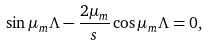Convert formula to latex. <formula><loc_0><loc_0><loc_500><loc_500>\sin \mu _ { m } \Lambda - \frac { 2 \mu _ { m } } { s } \cos \mu _ { m } \Lambda = 0 ,</formula> 